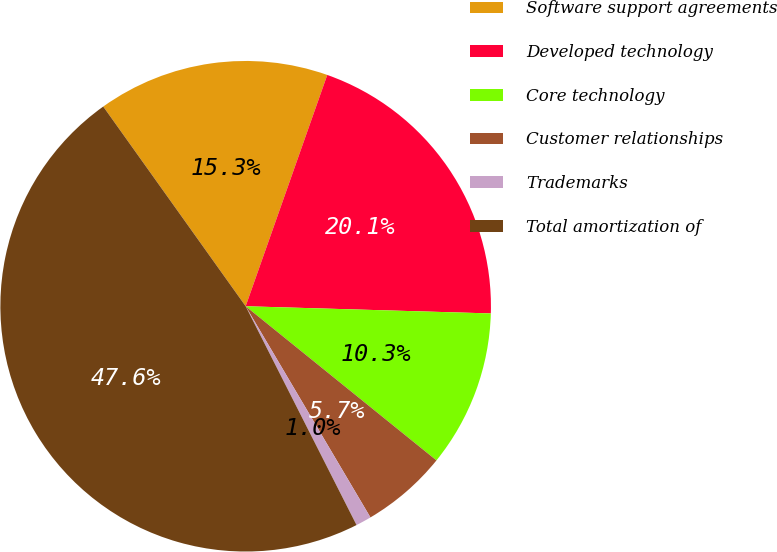Convert chart. <chart><loc_0><loc_0><loc_500><loc_500><pie_chart><fcel>Software support agreements<fcel>Developed technology<fcel>Core technology<fcel>Customer relationships<fcel>Trademarks<fcel>Total amortization of<nl><fcel>15.26%<fcel>20.07%<fcel>10.35%<fcel>5.69%<fcel>1.03%<fcel>47.61%<nl></chart> 